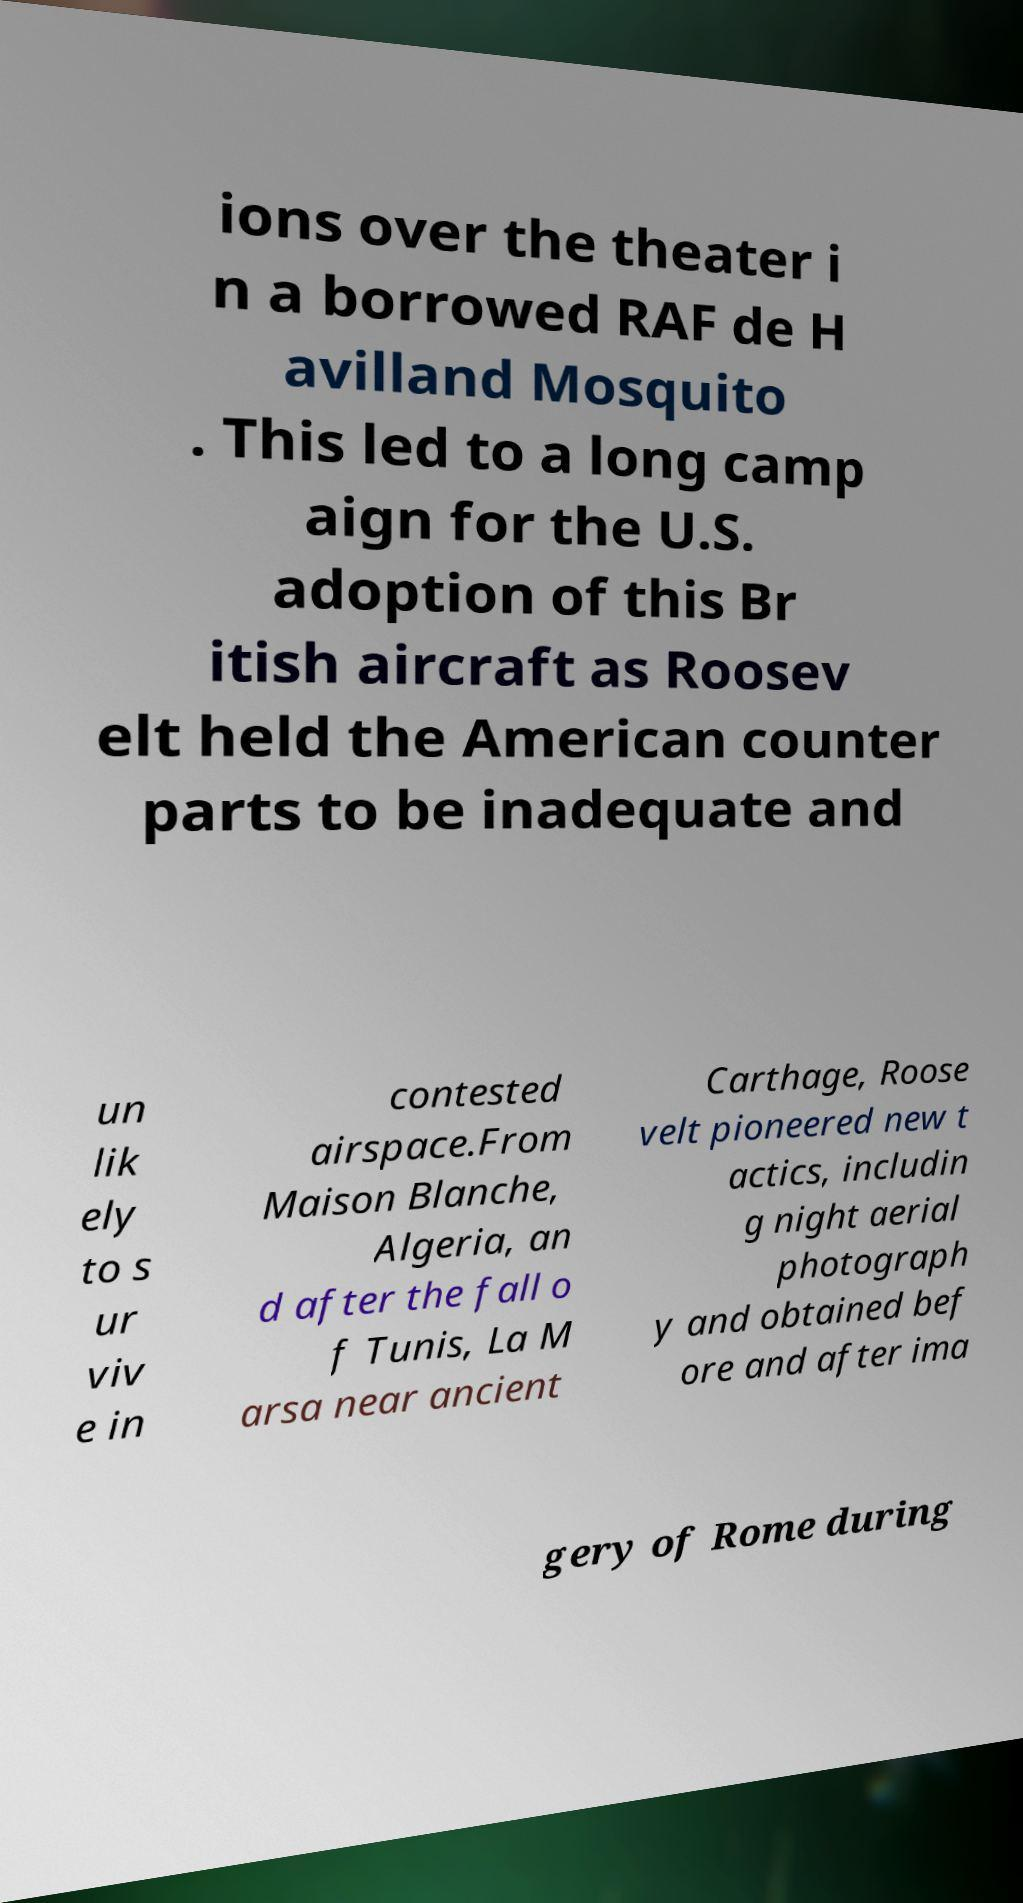Please read and relay the text visible in this image. What does it say? ions over the theater i n a borrowed RAF de H avilland Mosquito . This led to a long camp aign for the U.S. adoption of this Br itish aircraft as Roosev elt held the American counter parts to be inadequate and un lik ely to s ur viv e in contested airspace.From Maison Blanche, Algeria, an d after the fall o f Tunis, La M arsa near ancient Carthage, Roose velt pioneered new t actics, includin g night aerial photograph y and obtained bef ore and after ima gery of Rome during 